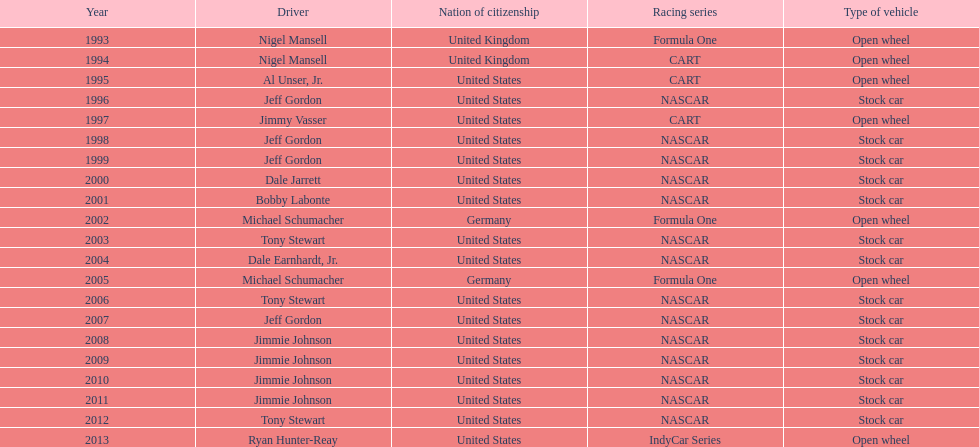Which driver secured espy awards with an 11-year gap between victories? Jeff Gordon. 